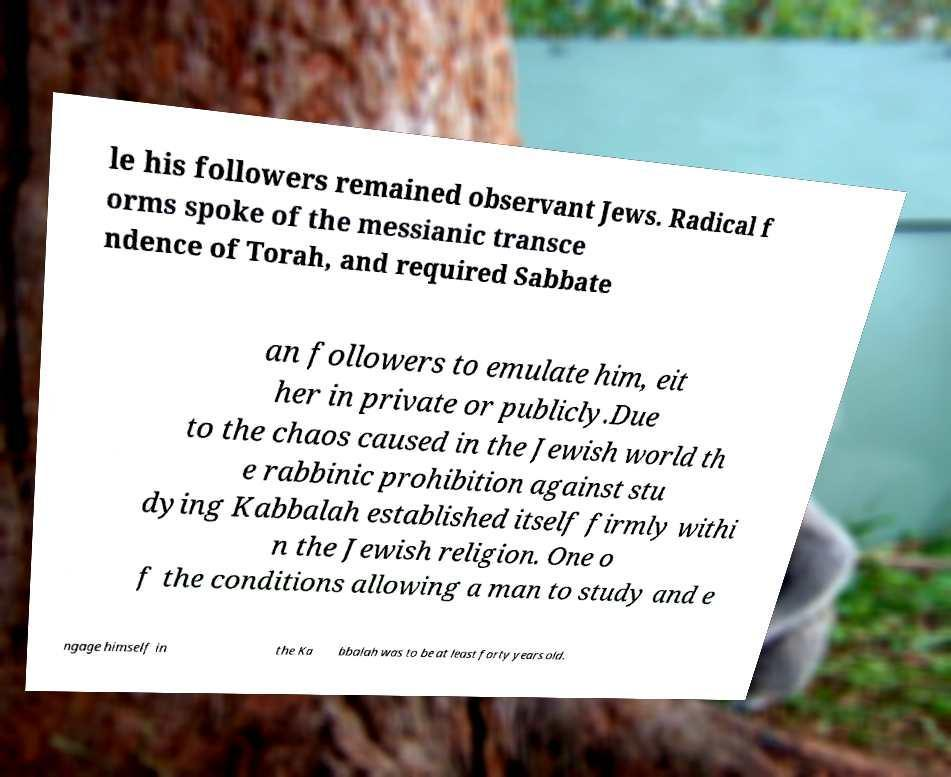Please identify and transcribe the text found in this image. le his followers remained observant Jews. Radical f orms spoke of the messianic transce ndence of Torah, and required Sabbate an followers to emulate him, eit her in private or publicly.Due to the chaos caused in the Jewish world th e rabbinic prohibition against stu dying Kabbalah established itself firmly withi n the Jewish religion. One o f the conditions allowing a man to study and e ngage himself in the Ka bbalah was to be at least forty years old. 